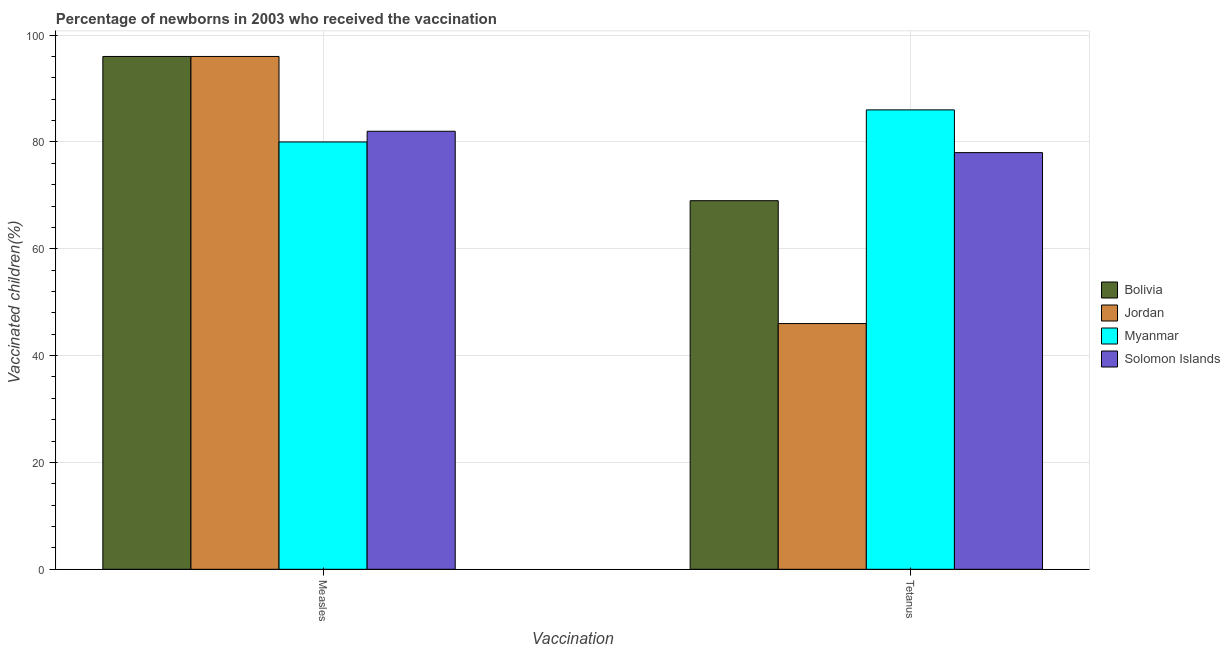How many different coloured bars are there?
Your answer should be very brief. 4. How many groups of bars are there?
Make the answer very short. 2. Are the number of bars per tick equal to the number of legend labels?
Offer a very short reply. Yes. How many bars are there on the 1st tick from the right?
Provide a succinct answer. 4. What is the label of the 2nd group of bars from the left?
Give a very brief answer. Tetanus. What is the percentage of newborns who received vaccination for measles in Jordan?
Your response must be concise. 96. Across all countries, what is the maximum percentage of newborns who received vaccination for measles?
Provide a short and direct response. 96. Across all countries, what is the minimum percentage of newborns who received vaccination for tetanus?
Ensure brevity in your answer.  46. In which country was the percentage of newborns who received vaccination for tetanus maximum?
Ensure brevity in your answer.  Myanmar. In which country was the percentage of newborns who received vaccination for measles minimum?
Offer a very short reply. Myanmar. What is the total percentage of newborns who received vaccination for measles in the graph?
Keep it short and to the point. 354. What is the difference between the percentage of newborns who received vaccination for tetanus in Myanmar and that in Jordan?
Offer a very short reply. 40. What is the difference between the percentage of newborns who received vaccination for measles in Myanmar and the percentage of newborns who received vaccination for tetanus in Solomon Islands?
Offer a very short reply. 2. What is the average percentage of newborns who received vaccination for measles per country?
Your answer should be very brief. 88.5. What is the difference between the percentage of newborns who received vaccination for measles and percentage of newborns who received vaccination for tetanus in Jordan?
Provide a succinct answer. 50. What is the ratio of the percentage of newborns who received vaccination for measles in Bolivia to that in Solomon Islands?
Your answer should be very brief. 1.17. Is the percentage of newborns who received vaccination for measles in Bolivia less than that in Myanmar?
Offer a terse response. No. In how many countries, is the percentage of newborns who received vaccination for measles greater than the average percentage of newborns who received vaccination for measles taken over all countries?
Your answer should be compact. 2. What does the 2nd bar from the left in Tetanus represents?
Provide a succinct answer. Jordan. What does the 1st bar from the right in Tetanus represents?
Keep it short and to the point. Solomon Islands. Are all the bars in the graph horizontal?
Your response must be concise. No. What is the difference between two consecutive major ticks on the Y-axis?
Keep it short and to the point. 20. Are the values on the major ticks of Y-axis written in scientific E-notation?
Your answer should be compact. No. Does the graph contain grids?
Keep it short and to the point. Yes. Where does the legend appear in the graph?
Provide a short and direct response. Center right. How are the legend labels stacked?
Offer a very short reply. Vertical. What is the title of the graph?
Make the answer very short. Percentage of newborns in 2003 who received the vaccination. What is the label or title of the X-axis?
Your response must be concise. Vaccination. What is the label or title of the Y-axis?
Your response must be concise. Vaccinated children(%)
. What is the Vaccinated children(%)
 of Bolivia in Measles?
Your answer should be compact. 96. What is the Vaccinated children(%)
 of Jordan in Measles?
Offer a terse response. 96. What is the Vaccinated children(%)
 in Solomon Islands in Measles?
Provide a short and direct response. 82. What is the Vaccinated children(%)
 of Bolivia in Tetanus?
Give a very brief answer. 69. Across all Vaccination, what is the maximum Vaccinated children(%)
 in Bolivia?
Give a very brief answer. 96. Across all Vaccination, what is the maximum Vaccinated children(%)
 in Jordan?
Make the answer very short. 96. Across all Vaccination, what is the maximum Vaccinated children(%)
 of Myanmar?
Provide a short and direct response. 86. Across all Vaccination, what is the minimum Vaccinated children(%)
 in Myanmar?
Your answer should be very brief. 80. What is the total Vaccinated children(%)
 in Bolivia in the graph?
Provide a succinct answer. 165. What is the total Vaccinated children(%)
 in Jordan in the graph?
Make the answer very short. 142. What is the total Vaccinated children(%)
 of Myanmar in the graph?
Give a very brief answer. 166. What is the total Vaccinated children(%)
 of Solomon Islands in the graph?
Offer a terse response. 160. What is the difference between the Vaccinated children(%)
 in Jordan in Measles and that in Tetanus?
Make the answer very short. 50. What is the difference between the Vaccinated children(%)
 of Myanmar in Measles and that in Tetanus?
Make the answer very short. -6. What is the difference between the Vaccinated children(%)
 in Solomon Islands in Measles and that in Tetanus?
Provide a short and direct response. 4. What is the difference between the Vaccinated children(%)
 in Bolivia in Measles and the Vaccinated children(%)
 in Solomon Islands in Tetanus?
Your answer should be very brief. 18. What is the difference between the Vaccinated children(%)
 of Jordan in Measles and the Vaccinated children(%)
 of Solomon Islands in Tetanus?
Give a very brief answer. 18. What is the average Vaccinated children(%)
 of Bolivia per Vaccination?
Keep it short and to the point. 82.5. What is the average Vaccinated children(%)
 in Jordan per Vaccination?
Offer a very short reply. 71. What is the average Vaccinated children(%)
 of Solomon Islands per Vaccination?
Make the answer very short. 80. What is the difference between the Vaccinated children(%)
 of Jordan and Vaccinated children(%)
 of Myanmar in Measles?
Offer a very short reply. 16. What is the difference between the Vaccinated children(%)
 of Jordan and Vaccinated children(%)
 of Solomon Islands in Measles?
Give a very brief answer. 14. What is the difference between the Vaccinated children(%)
 in Myanmar and Vaccinated children(%)
 in Solomon Islands in Measles?
Your answer should be very brief. -2. What is the difference between the Vaccinated children(%)
 in Bolivia and Vaccinated children(%)
 in Jordan in Tetanus?
Make the answer very short. 23. What is the difference between the Vaccinated children(%)
 in Bolivia and Vaccinated children(%)
 in Myanmar in Tetanus?
Your answer should be compact. -17. What is the difference between the Vaccinated children(%)
 of Jordan and Vaccinated children(%)
 of Myanmar in Tetanus?
Provide a short and direct response. -40. What is the difference between the Vaccinated children(%)
 in Jordan and Vaccinated children(%)
 in Solomon Islands in Tetanus?
Provide a succinct answer. -32. What is the ratio of the Vaccinated children(%)
 of Bolivia in Measles to that in Tetanus?
Offer a very short reply. 1.39. What is the ratio of the Vaccinated children(%)
 in Jordan in Measles to that in Tetanus?
Make the answer very short. 2.09. What is the ratio of the Vaccinated children(%)
 of Myanmar in Measles to that in Tetanus?
Offer a terse response. 0.93. What is the ratio of the Vaccinated children(%)
 of Solomon Islands in Measles to that in Tetanus?
Ensure brevity in your answer.  1.05. What is the difference between the highest and the second highest Vaccinated children(%)
 of Jordan?
Provide a succinct answer. 50. What is the difference between the highest and the lowest Vaccinated children(%)
 of Myanmar?
Your answer should be compact. 6. 